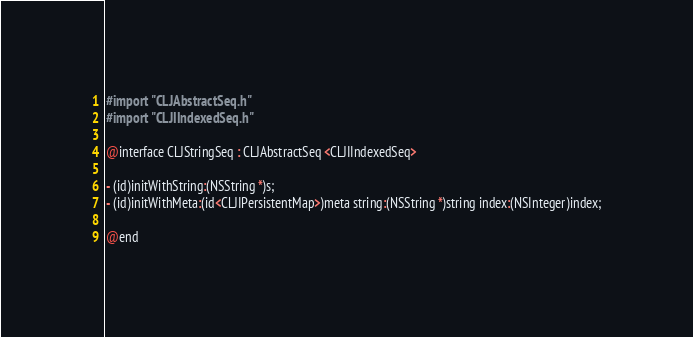<code> <loc_0><loc_0><loc_500><loc_500><_C_>
#import "CLJAbstractSeq.h"
#import "CLJIIndexedSeq.h"

@interface CLJStringSeq : CLJAbstractSeq <CLJIIndexedSeq>

- (id)initWithString:(NSString *)s;
- (id)initWithMeta:(id<CLJIPersistentMap>)meta string:(NSString *)string index:(NSInteger)index;

@end
</code> 